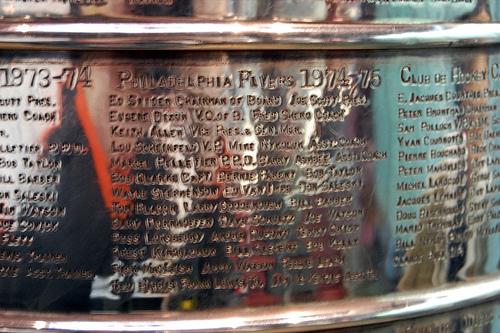What city is mentioned on the bronze?
Quick response, please. Philadelphia. Which Hockey Team are we looking at?
Answer briefly. Philadelphia flyers. Is there a reflection?
Write a very short answer. Yes. 